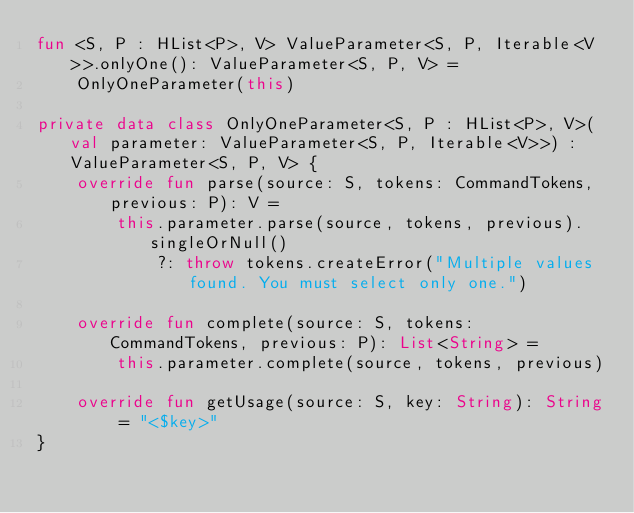Convert code to text. <code><loc_0><loc_0><loc_500><loc_500><_Kotlin_>fun <S, P : HList<P>, V> ValueParameter<S, P, Iterable<V>>.onlyOne(): ValueParameter<S, P, V> =
    OnlyOneParameter(this)

private data class OnlyOneParameter<S, P : HList<P>, V>(val parameter: ValueParameter<S, P, Iterable<V>>) : ValueParameter<S, P, V> {
    override fun parse(source: S, tokens: CommandTokens, previous: P): V =
        this.parameter.parse(source, tokens, previous).singleOrNull()
            ?: throw tokens.createError("Multiple values found. You must select only one.")

    override fun complete(source: S, tokens: CommandTokens, previous: P): List<String> =
        this.parameter.complete(source, tokens, previous)

    override fun getUsage(source: S, key: String): String = "<$key>"
}</code> 